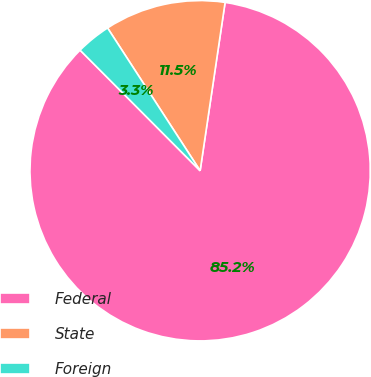<chart> <loc_0><loc_0><loc_500><loc_500><pie_chart><fcel>Federal<fcel>State<fcel>Foreign<nl><fcel>85.19%<fcel>11.5%<fcel>3.31%<nl></chart> 